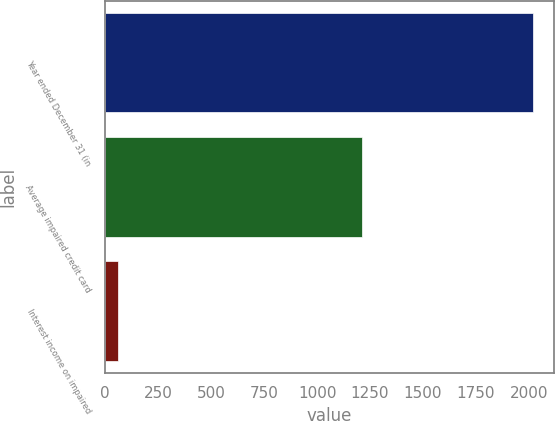Convert chart to OTSL. <chart><loc_0><loc_0><loc_500><loc_500><bar_chart><fcel>Year ended December 31 (in<fcel>Average impaired credit card<fcel>Interest income on impaired<nl><fcel>2017<fcel>1214<fcel>59<nl></chart> 